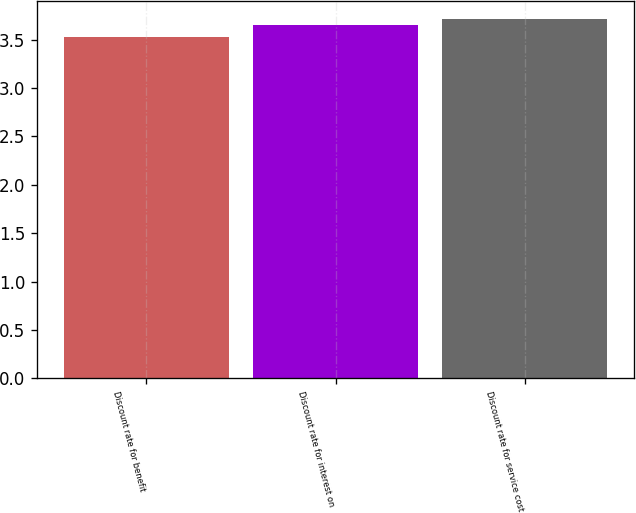Convert chart to OTSL. <chart><loc_0><loc_0><loc_500><loc_500><bar_chart><fcel>Discount rate for benefit<fcel>Discount rate for interest on<fcel>Discount rate for service cost<nl><fcel>3.53<fcel>3.65<fcel>3.72<nl></chart> 